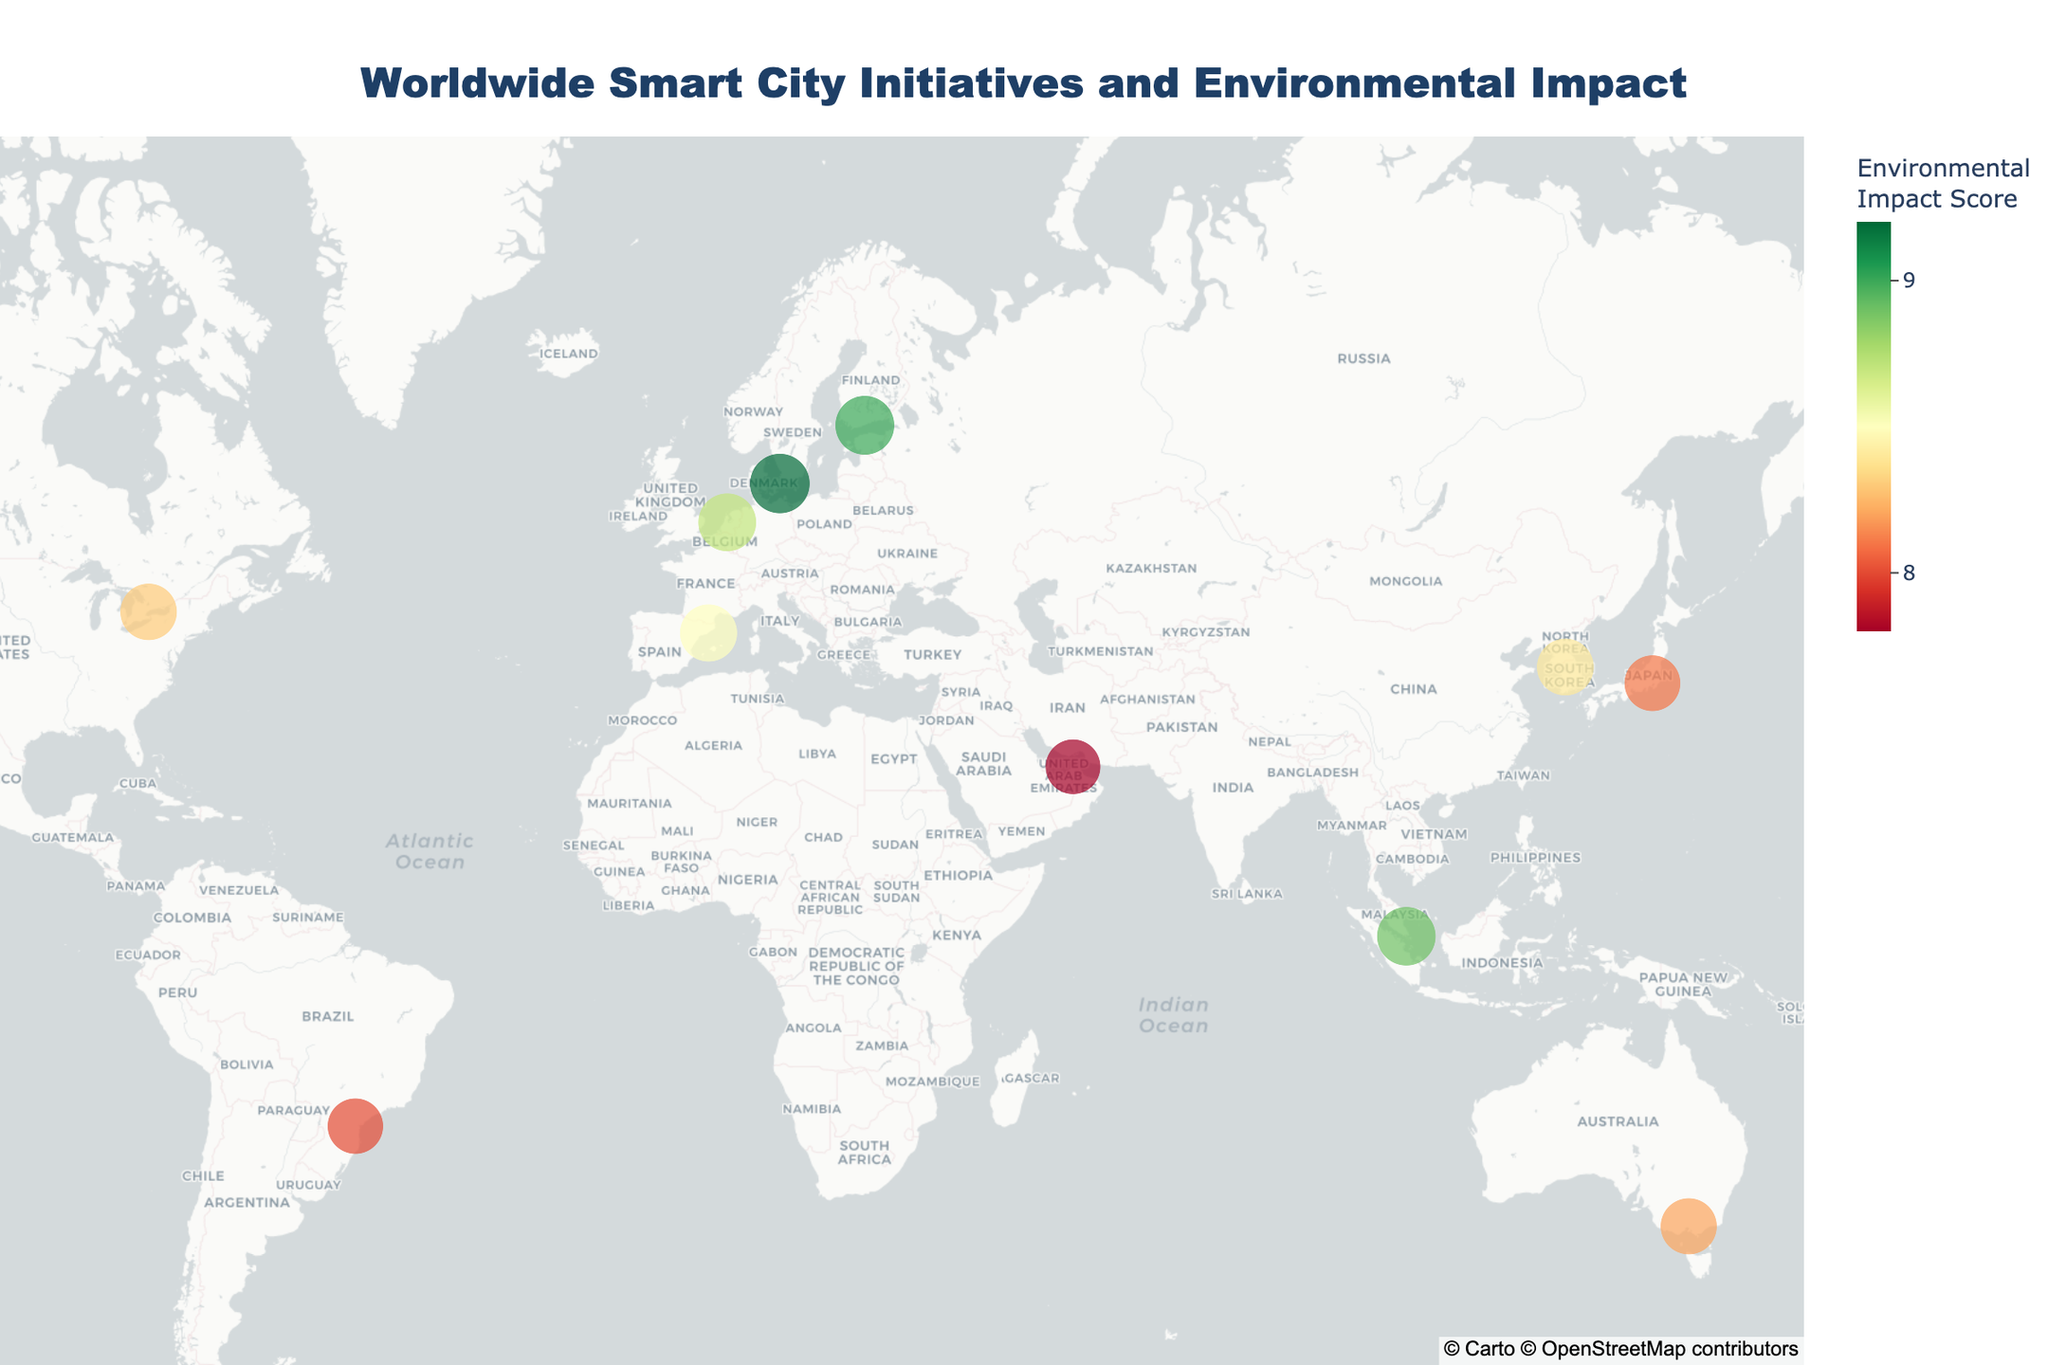What's the title of the figure? The figure title is typically displayed at the top of the chart. It provides a summary of what the figure is about. In this case, it states the overall topic of the map.
Answer: "Worldwide Smart City Initiatives and Environmental Impact" How many smart city initiatives are plotted on the map? Each data point on the map represents a city with a smart city initiative. By counting the distinct data points on the map, we get the total number of initiatives shown.
Answer: 12 Which city has the highest Environmental Impact Score on the map? To determine this, we look for the data point with the largest size and the darkest shade of green (indicating the highest score). Checking the hover information for the highest value confirms this.
Answer: Copenhagen Which city is located in the southernmost part of the map? To find the southernmost city, we identify the city with the lowest latitude value (negative latitude values indicate the Southern Hemisphere). In this case, we can identify it visually by the lowest placement on the map.
Answer: Melbourne What is the combined Environmental Impact Score of Tokyo and Dubai? We need to sum the individual Environmental Impact Scores of Tokyo and Dubai. Tokyo has a score of 8.1 and Dubai has a score of 7.8, adding these together gives the combined score.
Answer: 15.9 Which city focuses on Smart Energy Grid and what is its Environmental Impact Score? By examining the hover information on the map, we can identify the city associated with the "Smart Energy Grid" initiative. The corresponding Environmental Impact Score is also displayed in the hover data.
Answer: Amsterdam, 8.7 Is there a city with an Environmental Impact Score of 9 on the map? If so, which city is it? By examining the color scale and hover information, we check if any city has a score equal to 9.
Answer: Yes, Helsinki Which city in North America has a higher Environmental Impact Score: Toronto or San Francisco? We compare the Environmental Impact Scores of Toronto and San Francisco from their respective data points on the map.
Answer: San Francisco What is the average Environmental Impact Score of all the cities in Asia on the map? First, identify the cities in Asia (Singapore, Tokyo, and Seoul) and then calculate their average score: (8.9 + 8.1 + 8.4) / 3.
Answer: 8.47 Among the cities focusing on transportation-related initiatives, which one has the lowest Environmental Impact Score? Identify the transportation-focused cities (Barcelona and Dubai), then compare their scores to determine the lowest.
Answer: Dubai 